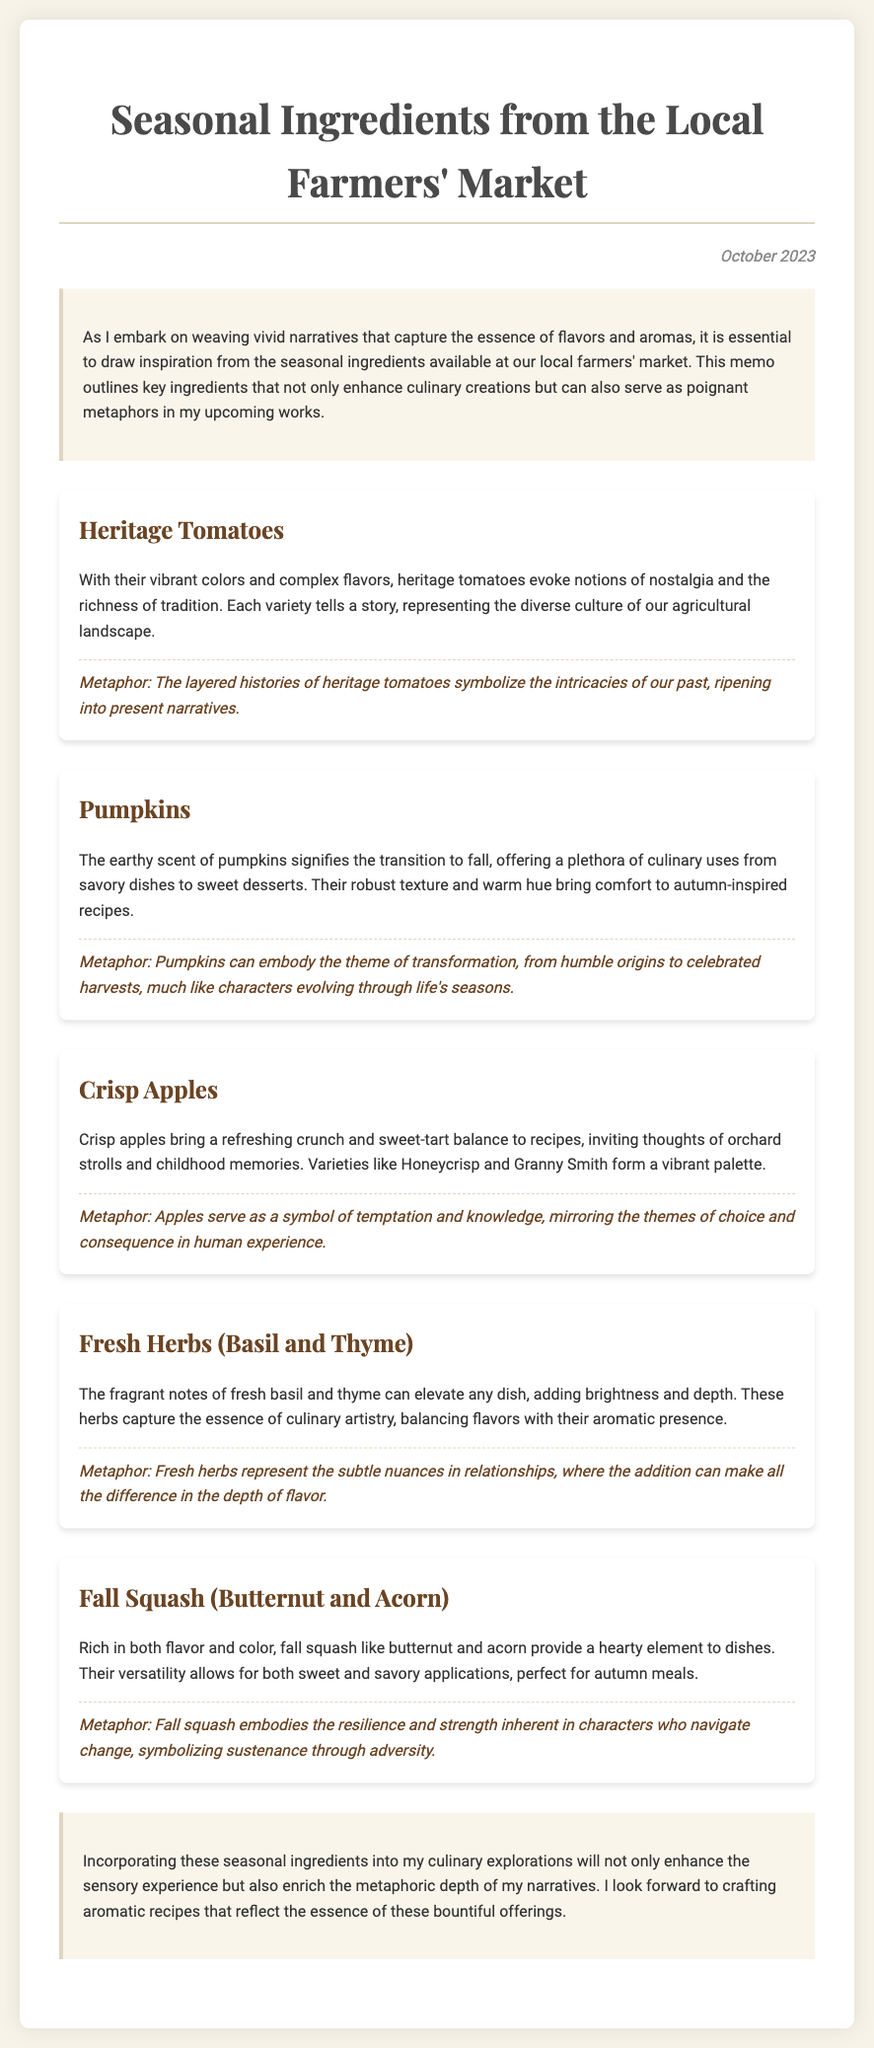What is the title of the memo? The title of the memo is found at the top of the document.
Answer: Seasonal Ingredients from the Local Farmers' Market When was the memo published? The publication date of the memo is provided in the date section.
Answer: October 2023 What ingredient symbolizes the theme of transformation? The specific ingredient representing transformation is mentioned in its description and metaphor.
Answer: Pumpkins Which fresh herbs are highlighted in the memo? The memo lists the fresh herbs discussed within its content.
Answer: Basil and Thyme What do heritage tomatoes represent? The document outlines the significance of heritage tomatoes in the context of narrative and metaphor.
Answer: Nostalgia and the richness of tradition How do crisp apples contribute to recipes? The role of crisp apples in recipes is described in the context of flavor and memory.
Answer: Refreshing crunch and sweet-tart balance What metaphor is associated with fresh herbs? Each ingredient has a metaphor associated with it, and the metaphor for fresh herbs is specifically mentioned.
Answer: Subtle nuances in relationships What is the overall conclusion regarding seasonal ingredients? The conclusion summarizes the importance of seasonal ingredients to the author's work.
Answer: Enhance sensory experience and enrich metaphoric depth 